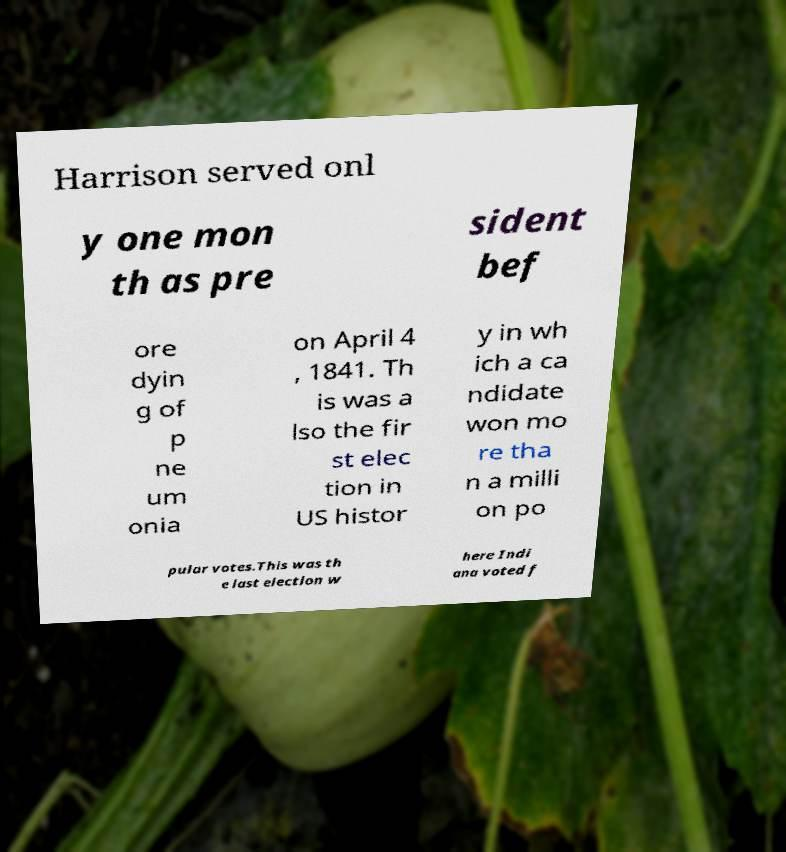Could you extract and type out the text from this image? Harrison served onl y one mon th as pre sident bef ore dyin g of p ne um onia on April 4 , 1841. Th is was a lso the fir st elec tion in US histor y in wh ich a ca ndidate won mo re tha n a milli on po pular votes.This was th e last election w here Indi ana voted f 